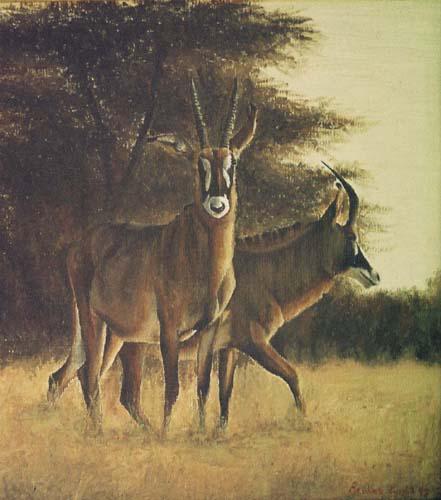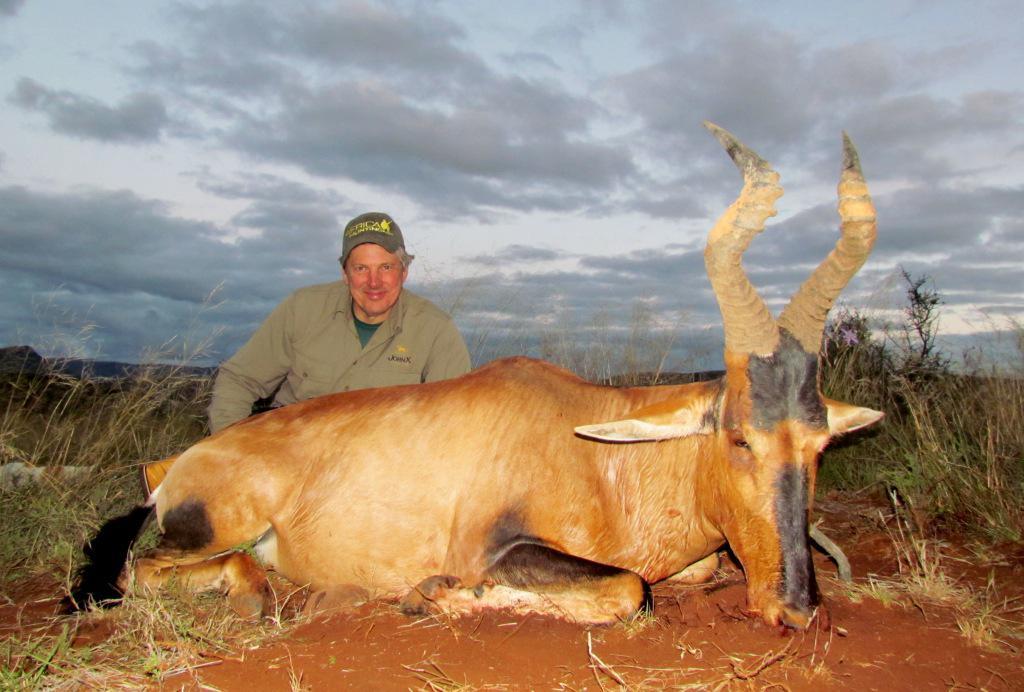The first image is the image on the left, the second image is the image on the right. For the images shown, is this caption "The left image includes more than twice the number of horned animals as the right image." true? Answer yes or no. No. The first image is the image on the left, the second image is the image on the right. Examine the images to the left and right. Is the description "There is exactly one animal standing in the right image." accurate? Answer yes or no. No. 